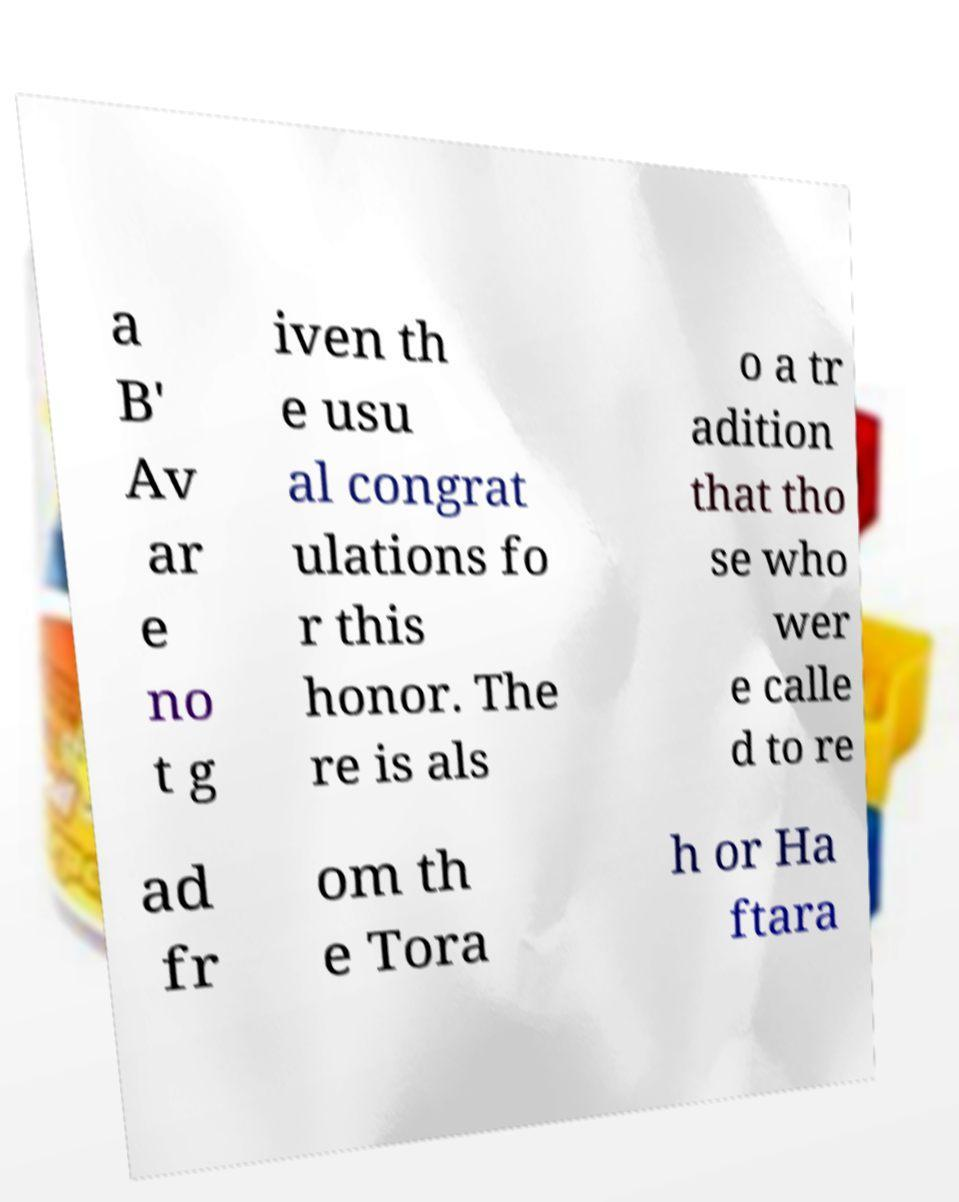What messages or text are displayed in this image? I need them in a readable, typed format. a B' Av ar e no t g iven th e usu al congrat ulations fo r this honor. The re is als o a tr adition that tho se who wer e calle d to re ad fr om th e Tora h or Ha ftara 